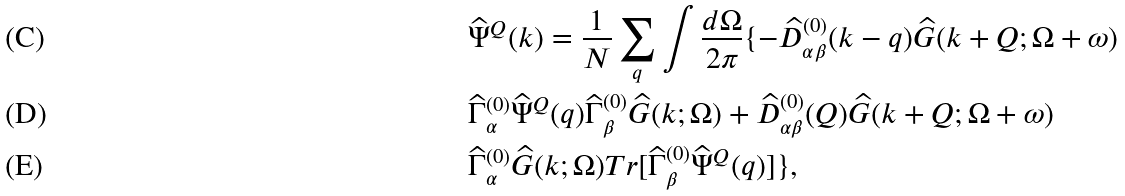<formula> <loc_0><loc_0><loc_500><loc_500>& \widehat { \Psi } ^ { Q } ( k ) = \frac { 1 } { N } \sum _ { q } \int \frac { d \Omega } { 2 \pi } \{ - \widehat { D } ^ { ( 0 ) } _ { \alpha \beta } ( k - q ) \widehat { G } ( k + Q ; \Omega + \omega ) \\ & \widehat { \Gamma } ^ { ( 0 ) } _ { \alpha } \widehat { \Psi } ^ { Q } ( q ) \widehat { \Gamma } ^ { ( 0 ) } _ { \beta } \widehat { G } ( k ; \Omega ) + \widehat { D } ^ { ( 0 ) } _ { \alpha \beta } ( Q ) \widehat { G } ( k + Q ; \Omega + \omega ) \\ & \widehat { \Gamma } ^ { ( 0 ) } _ { \alpha } \widehat { G } ( k ; \Omega ) T r [ \widehat { \Gamma } ^ { ( 0 ) } _ { \beta } \widehat { \Psi } ^ { Q } ( q ) ] \} ,</formula> 